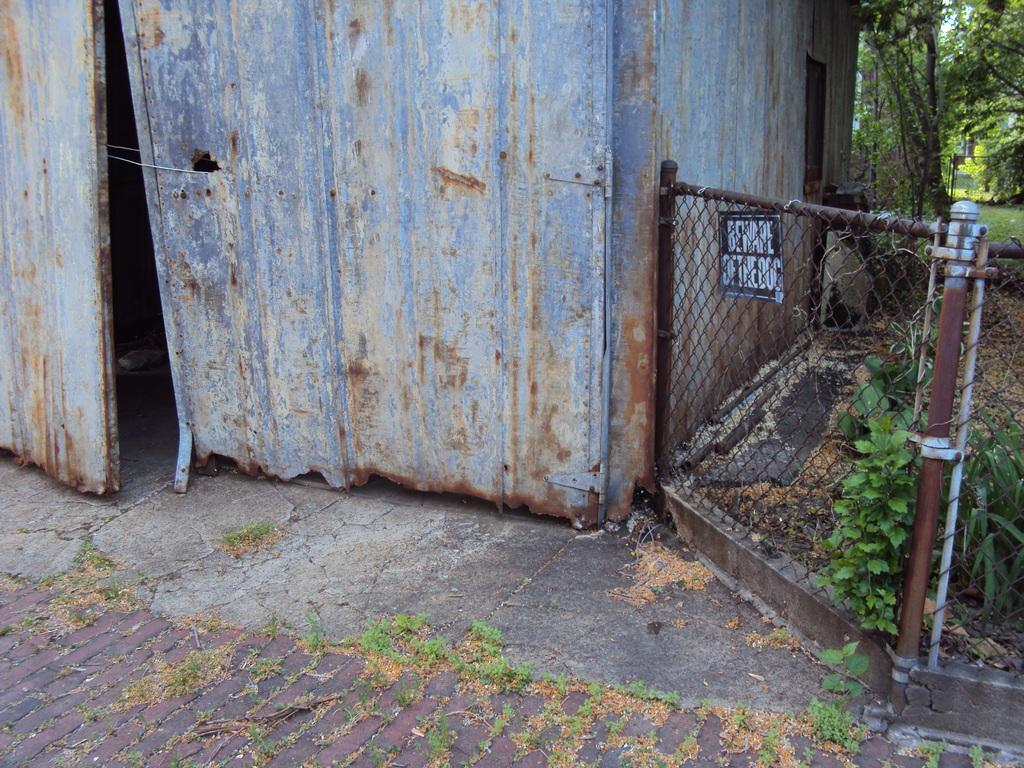How would you summarize this image in a sentence or two? In this image we can see shredded leaves on the floor, fences, sign boards, trees, creepers and shed. 